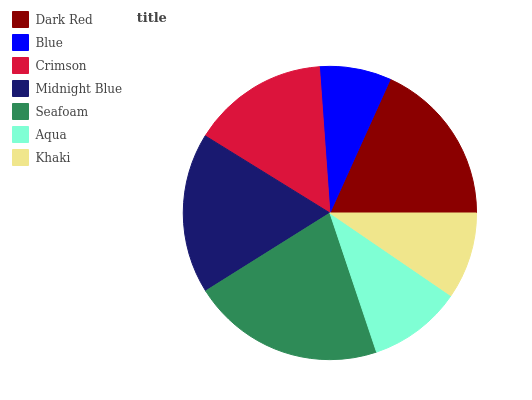Is Blue the minimum?
Answer yes or no. Yes. Is Seafoam the maximum?
Answer yes or no. Yes. Is Crimson the minimum?
Answer yes or no. No. Is Crimson the maximum?
Answer yes or no. No. Is Crimson greater than Blue?
Answer yes or no. Yes. Is Blue less than Crimson?
Answer yes or no. Yes. Is Blue greater than Crimson?
Answer yes or no. No. Is Crimson less than Blue?
Answer yes or no. No. Is Crimson the high median?
Answer yes or no. Yes. Is Crimson the low median?
Answer yes or no. Yes. Is Midnight Blue the high median?
Answer yes or no. No. Is Seafoam the low median?
Answer yes or no. No. 